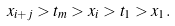Convert formula to latex. <formula><loc_0><loc_0><loc_500><loc_500>x _ { i + j } > t _ { m } > x _ { i } > t _ { 1 } > x _ { 1 } .</formula> 